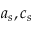Convert formula to latex. <formula><loc_0><loc_0><loc_500><loc_500>a _ { s } , c _ { s }</formula> 